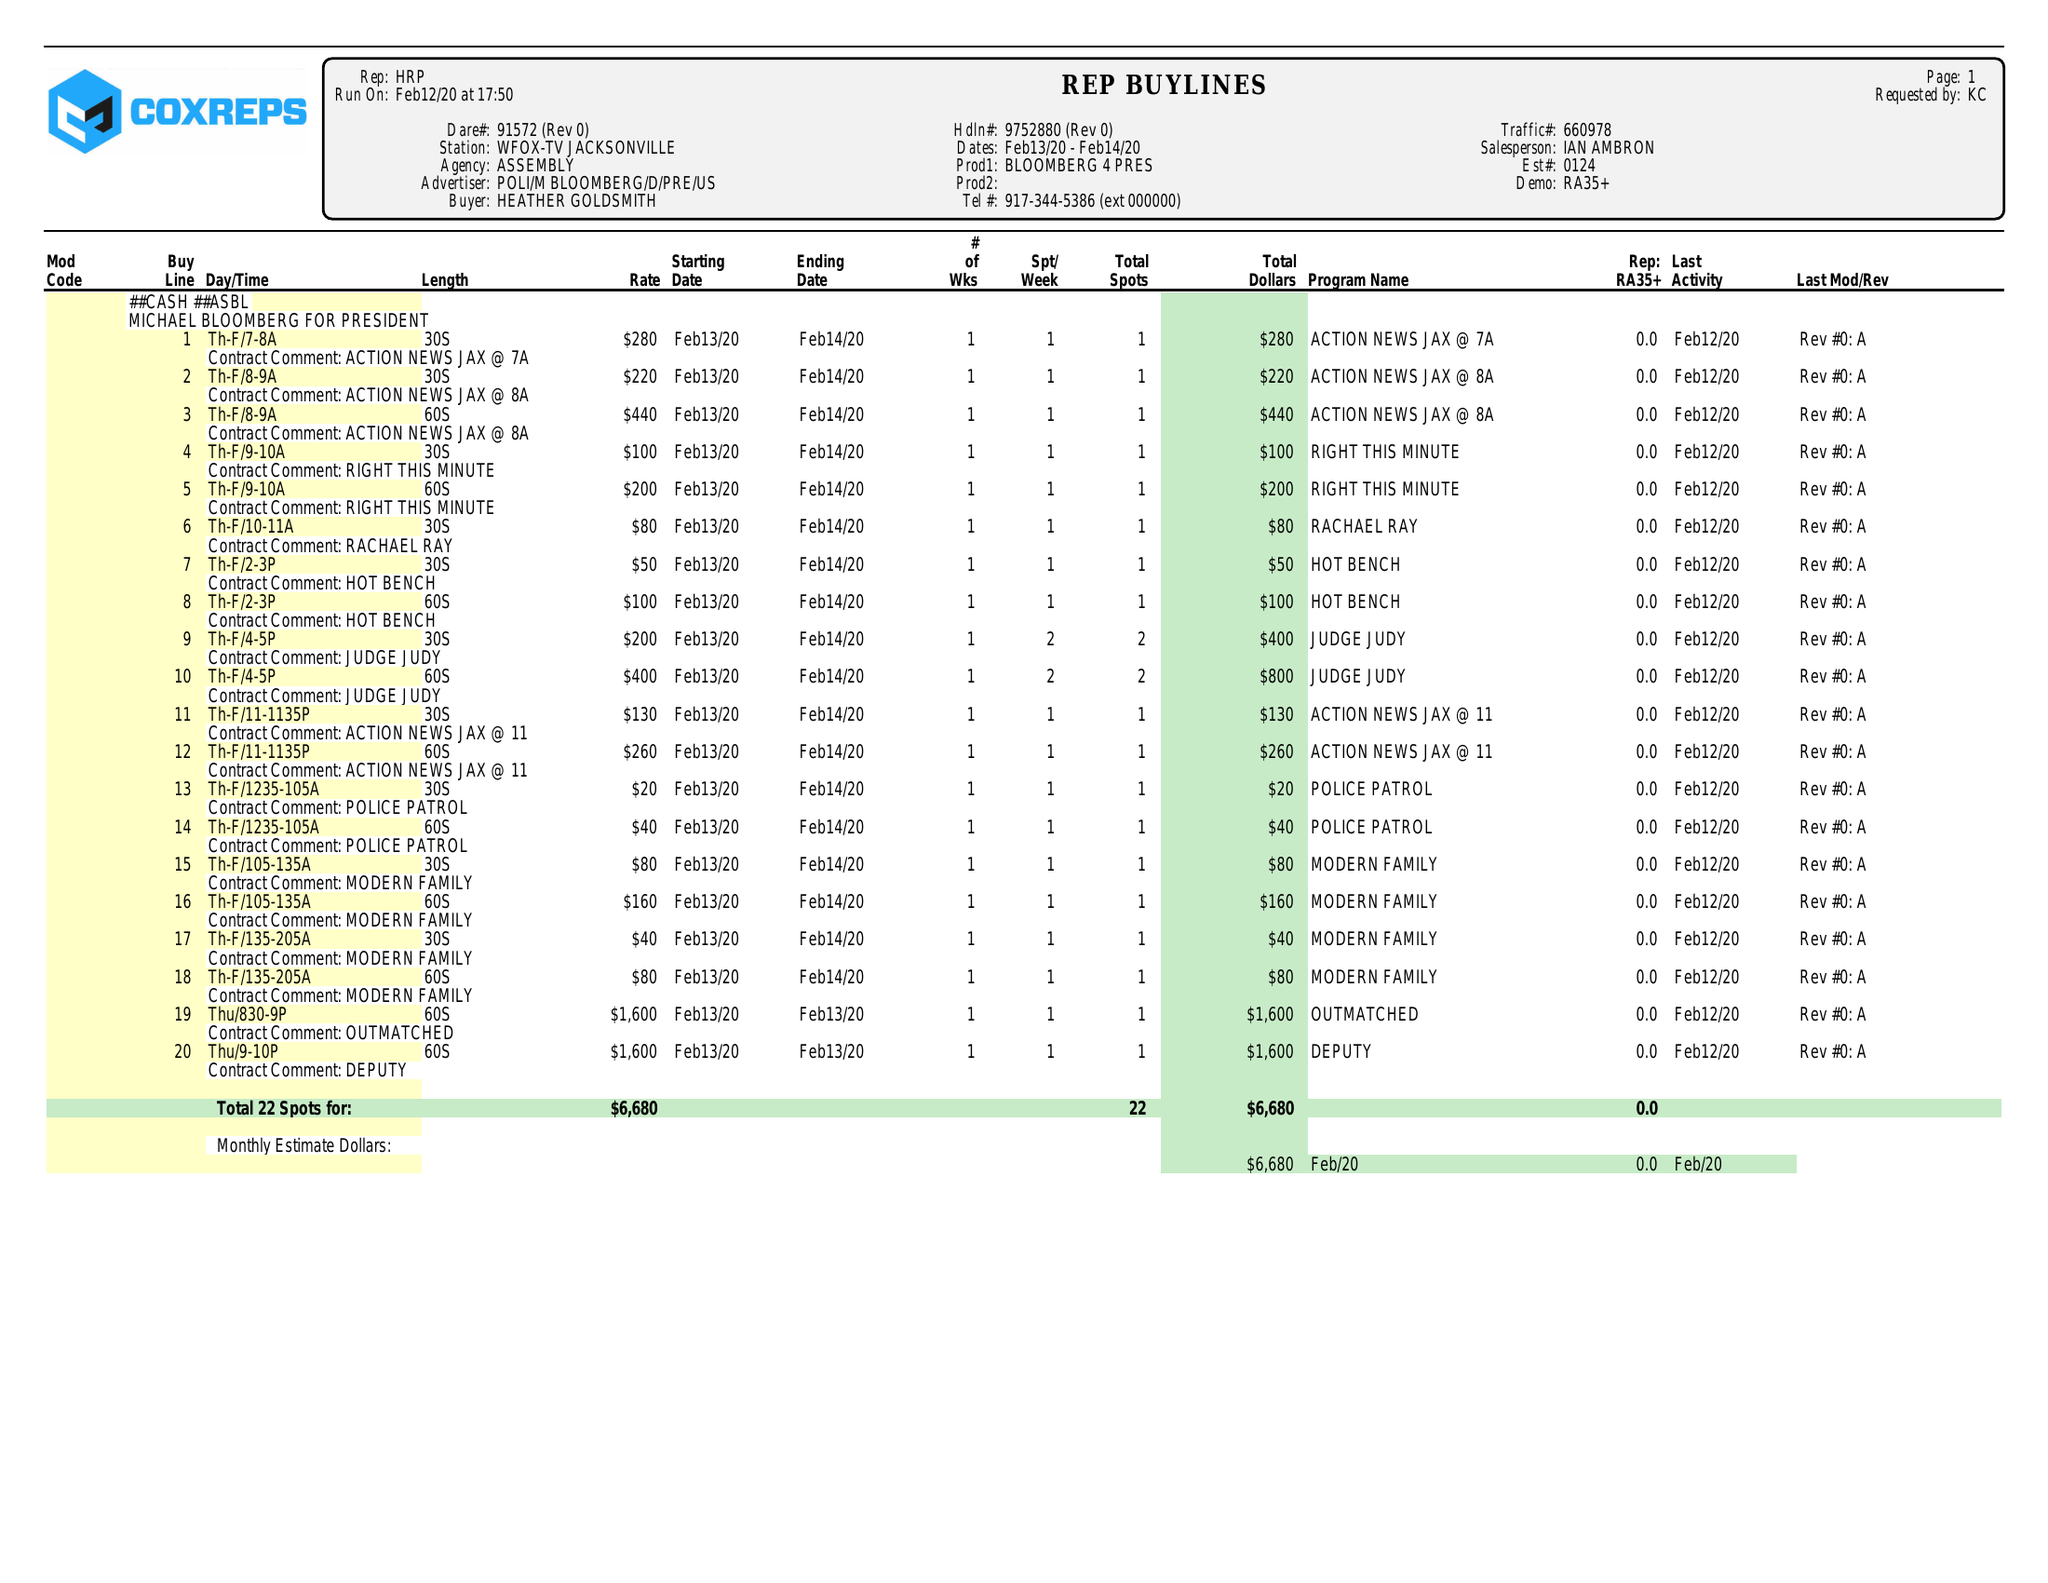What is the value for the gross_amount?
Answer the question using a single word or phrase. 6680.00 